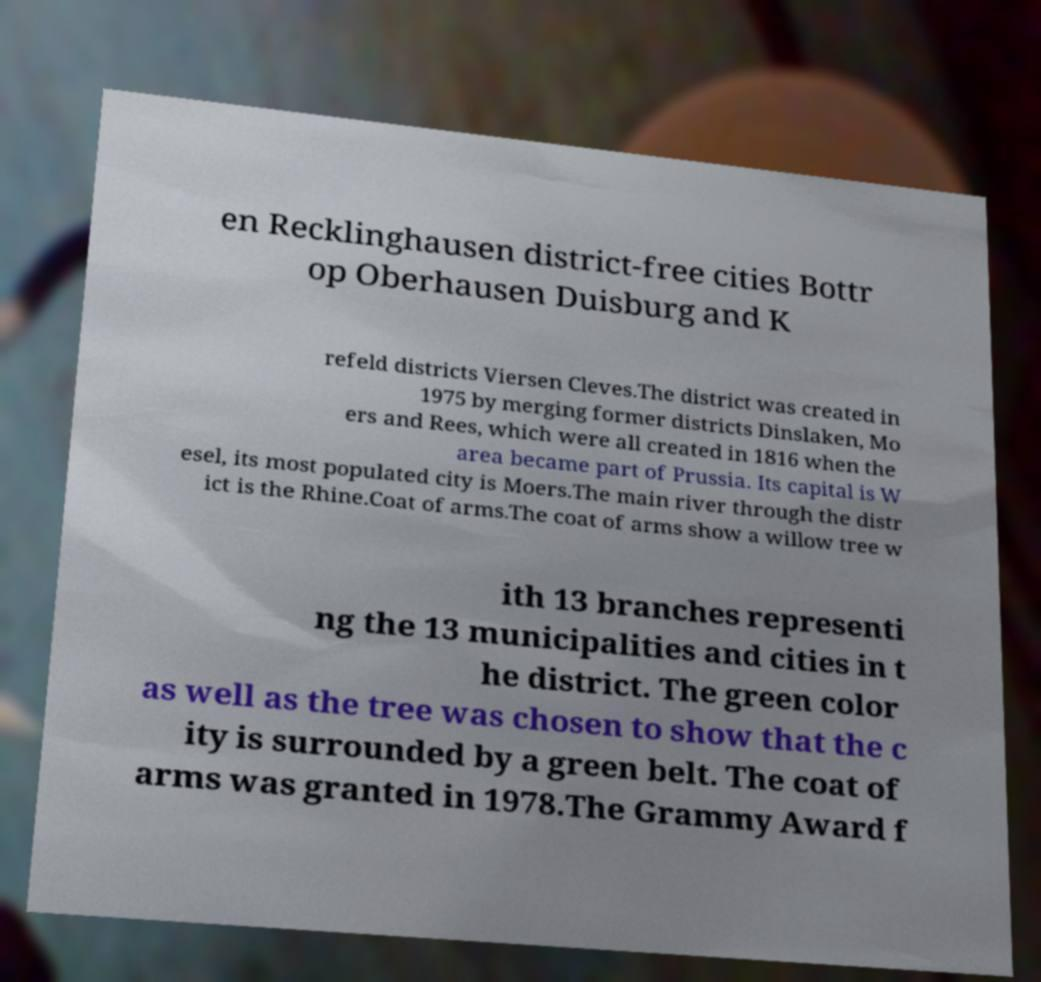Please read and relay the text visible in this image. What does it say? en Recklinghausen district-free cities Bottr op Oberhausen Duisburg and K refeld districts Viersen Cleves.The district was created in 1975 by merging former districts Dinslaken, Mo ers and Rees, which were all created in 1816 when the area became part of Prussia. Its capital is W esel, its most populated city is Moers.The main river through the distr ict is the Rhine.Coat of arms.The coat of arms show a willow tree w ith 13 branches representi ng the 13 municipalities and cities in t he district. The green color as well as the tree was chosen to show that the c ity is surrounded by a green belt. The coat of arms was granted in 1978.The Grammy Award f 